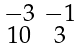Convert formula to latex. <formula><loc_0><loc_0><loc_500><loc_500>\begin{smallmatrix} - 3 & - 1 \\ 1 0 & 3 \end{smallmatrix}</formula> 